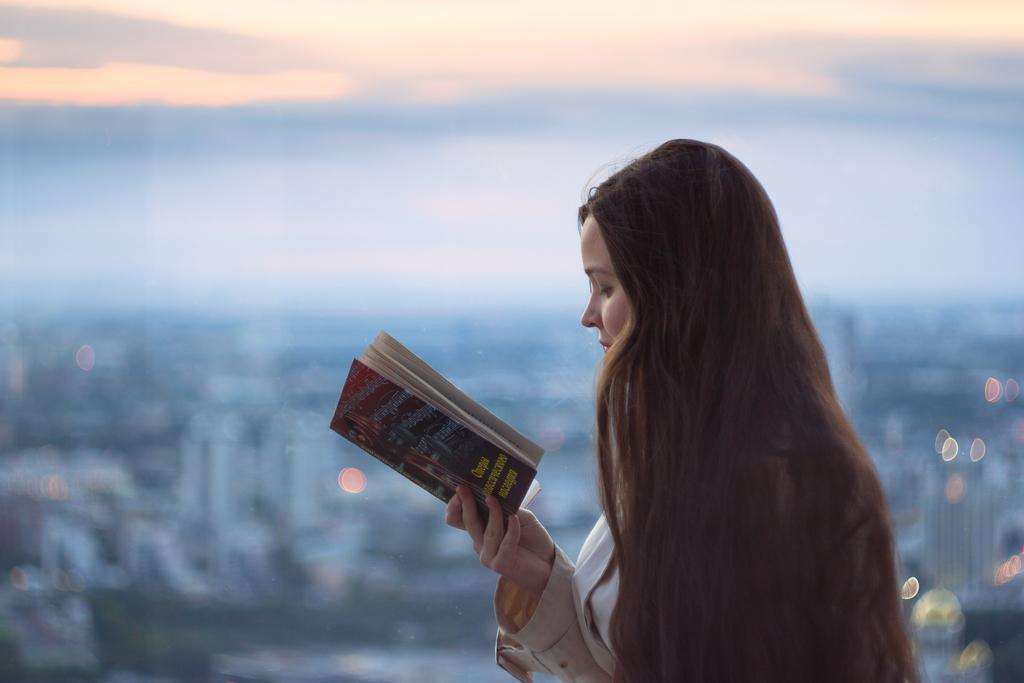Who is the main subject in the image? There is a woman in the image. What is the woman doing in the image? The woman is standing and holding a book in her hands. What can be seen in the background of the image? There are buildings and a clear sky visible in the background of the image. What type of advertisement can be seen on the grass in the image? There is no grass or advertisement present in the image. 